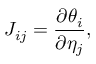Convert formula to latex. <formula><loc_0><loc_0><loc_500><loc_500>J _ { i j } = { \frac { \partial \theta _ { i } } { \partial \eta _ { j } } } ,</formula> 